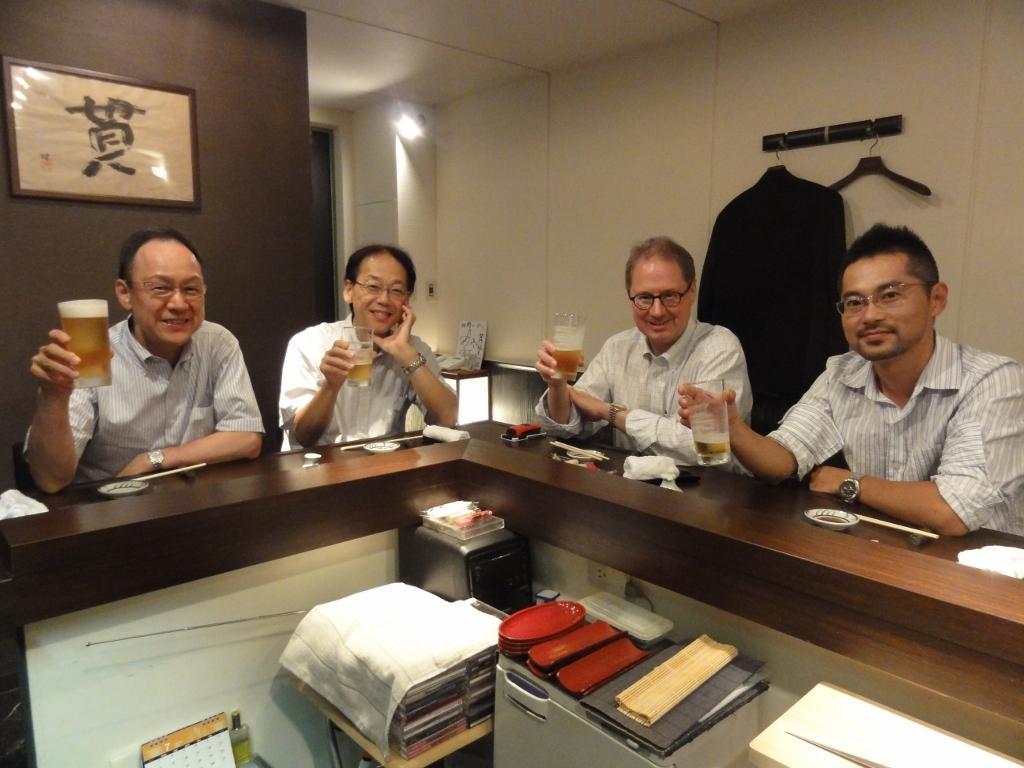Can you describe this image briefly? This picture is clicked inside the room. Here, we see four people sitting on chair near the table and four men are catching glass which contains beer in it. The the man on the right corner of this picture is wearing watch and he is even wearing spectacles and the man right to him is also wearing spectacles who is in white shirt. All all the four men are wearing spectacles and in front of this picture we can see books, CPU and calendar which is placed on the table and behind the man we can see a wall which is brown in color and we can even see a photo frame. To the right of this picture, we can see black blazer which is hanged to the hangers. 